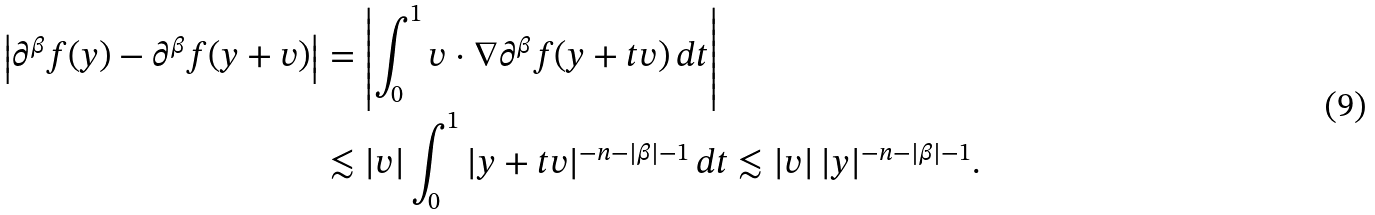Convert formula to latex. <formula><loc_0><loc_0><loc_500><loc_500>\left | \partial ^ { \beta } f ( y ) - \partial ^ { \beta } f ( y + v ) \right | & = \left | \int _ { 0 } ^ { 1 } v \cdot \nabla \partial ^ { \beta } f ( y + t v ) \, d t \right | \\ & \lesssim | v | \int _ { 0 } ^ { 1 } | y + t v | ^ { - n - | \beta | - 1 } \, d t \lesssim | v | \, | y | ^ { - n - | \beta | - 1 } .</formula> 